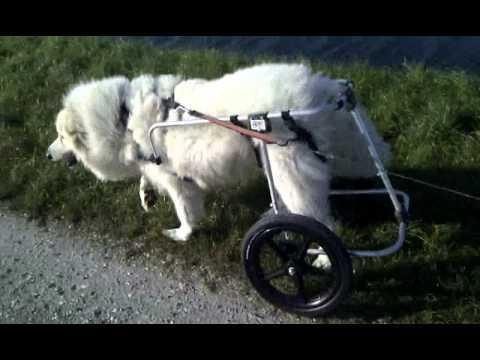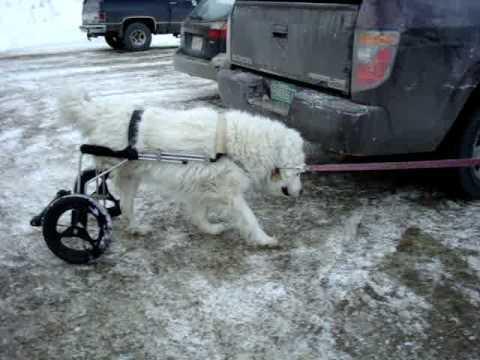The first image is the image on the left, the second image is the image on the right. Given the left and right images, does the statement "An animal in the image on the left has wheels." hold true? Answer yes or no. Yes. 